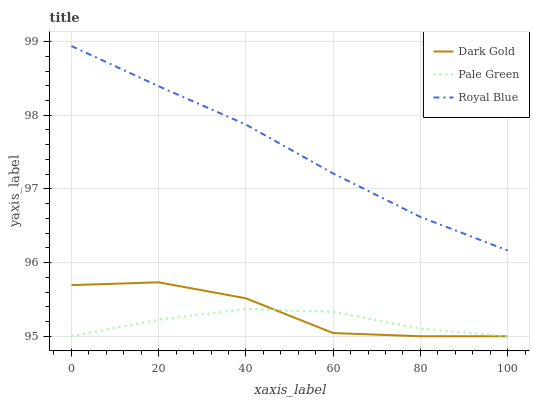Does Pale Green have the minimum area under the curve?
Answer yes or no. Yes. Does Royal Blue have the maximum area under the curve?
Answer yes or no. Yes. Does Dark Gold have the minimum area under the curve?
Answer yes or no. No. Does Dark Gold have the maximum area under the curve?
Answer yes or no. No. Is Royal Blue the smoothest?
Answer yes or no. Yes. Is Dark Gold the roughest?
Answer yes or no. Yes. Is Pale Green the smoothest?
Answer yes or no. No. Is Pale Green the roughest?
Answer yes or no. No. Does Dark Gold have the highest value?
Answer yes or no. No. Is Pale Green less than Royal Blue?
Answer yes or no. Yes. Is Royal Blue greater than Dark Gold?
Answer yes or no. Yes. Does Pale Green intersect Royal Blue?
Answer yes or no. No. 